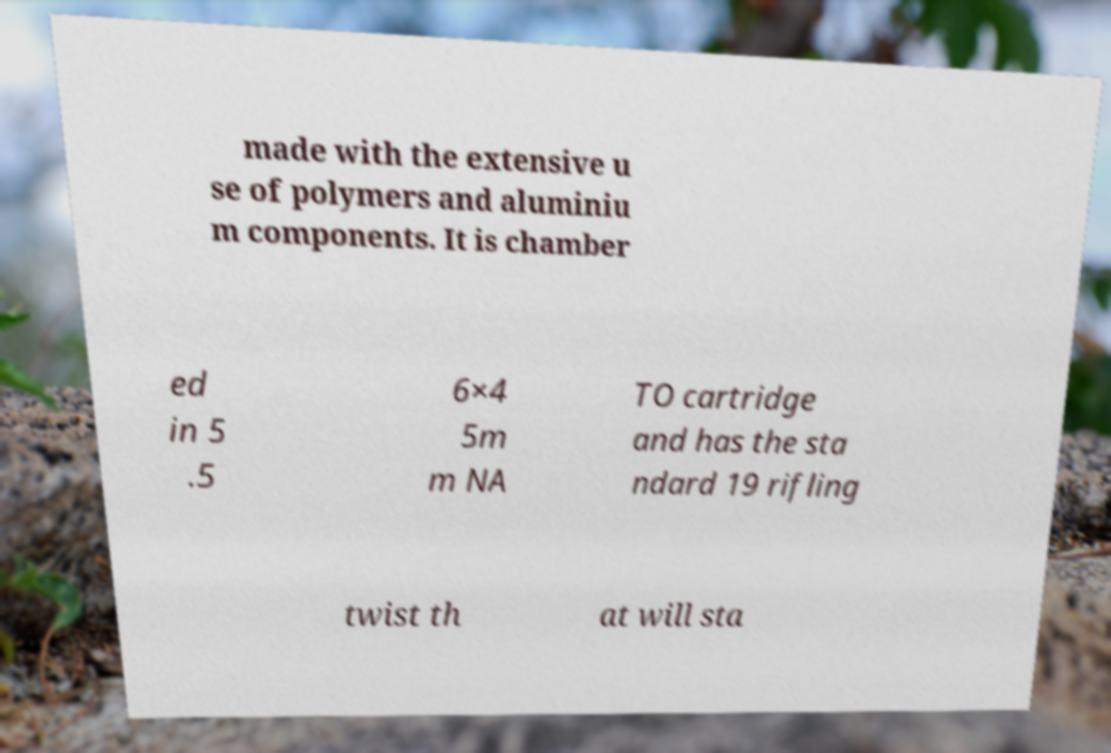Can you read and provide the text displayed in the image?This photo seems to have some interesting text. Can you extract and type it out for me? made with the extensive u se of polymers and aluminiu m components. It is chamber ed in 5 .5 6×4 5m m NA TO cartridge and has the sta ndard 19 rifling twist th at will sta 